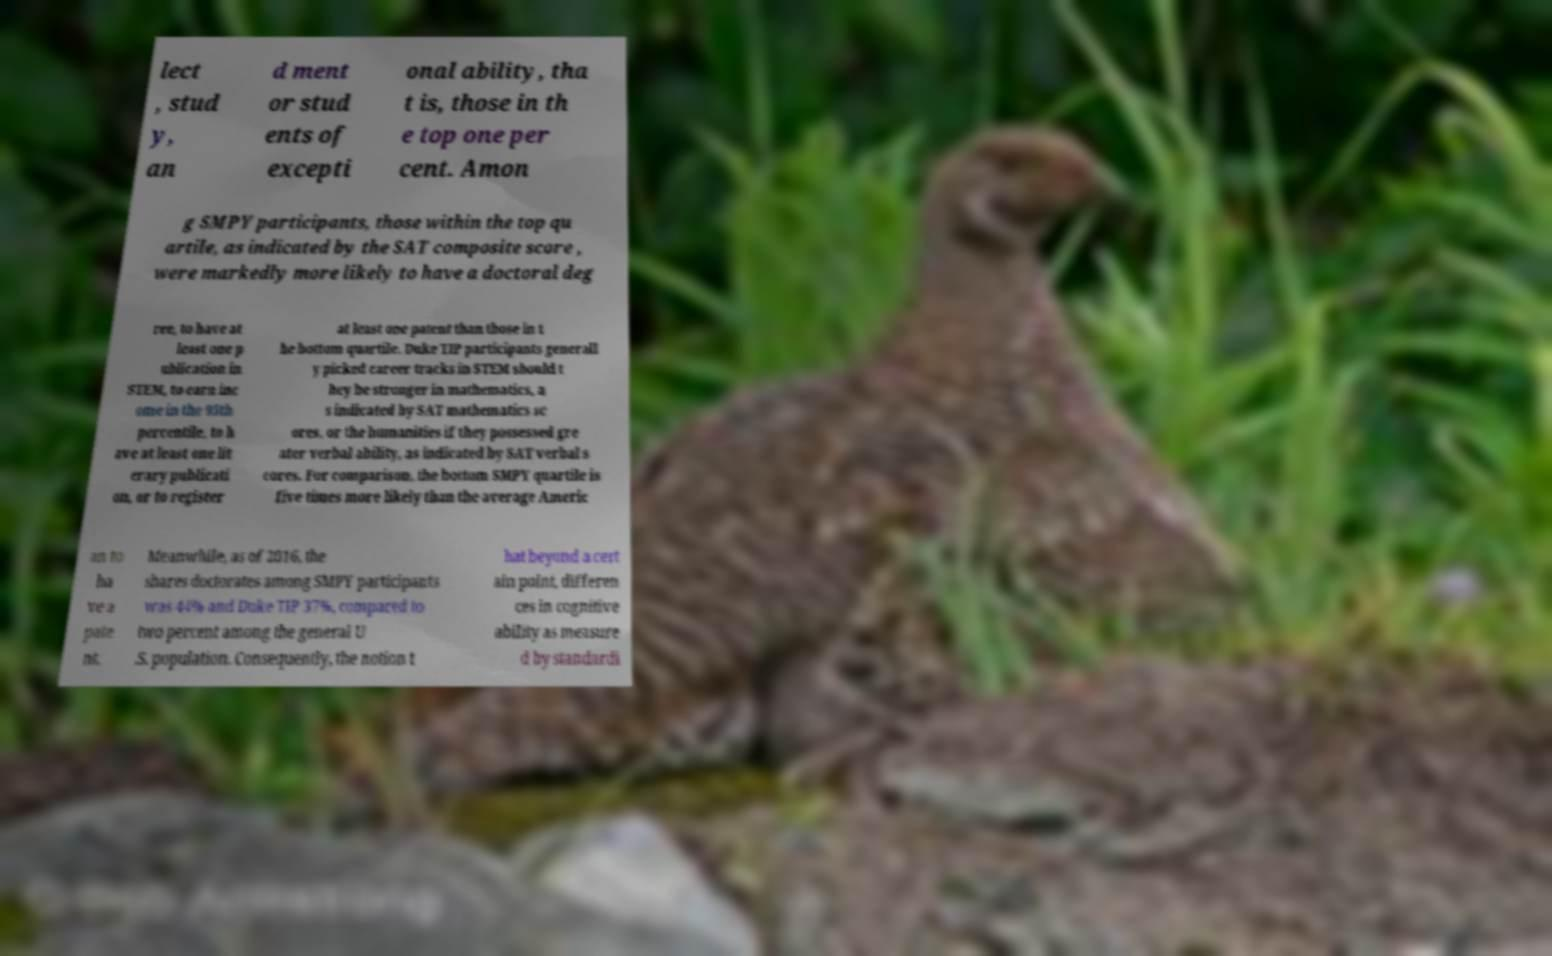For documentation purposes, I need the text within this image transcribed. Could you provide that? lect , stud y, an d ment or stud ents of excepti onal ability, tha t is, those in th e top one per cent. Amon g SMPY participants, those within the top qu artile, as indicated by the SAT composite score , were markedly more likely to have a doctoral deg ree, to have at least one p ublication in STEM, to earn inc ome in the 95th percentile, to h ave at least one lit erary publicati on, or to register at least one patent than those in t he bottom quartile. Duke TIP participants generall y picked career tracks in STEM should t hey be stronger in mathematics, a s indicated by SAT mathematics sc ores, or the humanities if they possessed gre ater verbal ability, as indicated by SAT verbal s cores. For comparison, the bottom SMPY quartile is five times more likely than the average Americ an to ha ve a pate nt. Meanwhile, as of 2016, the shares doctorates among SMPY participants was 44% and Duke TIP 37%, compared to two percent among the general U .S. population. Consequently, the notion t hat beyond a cert ain point, differen ces in cognitive ability as measure d by standardi 